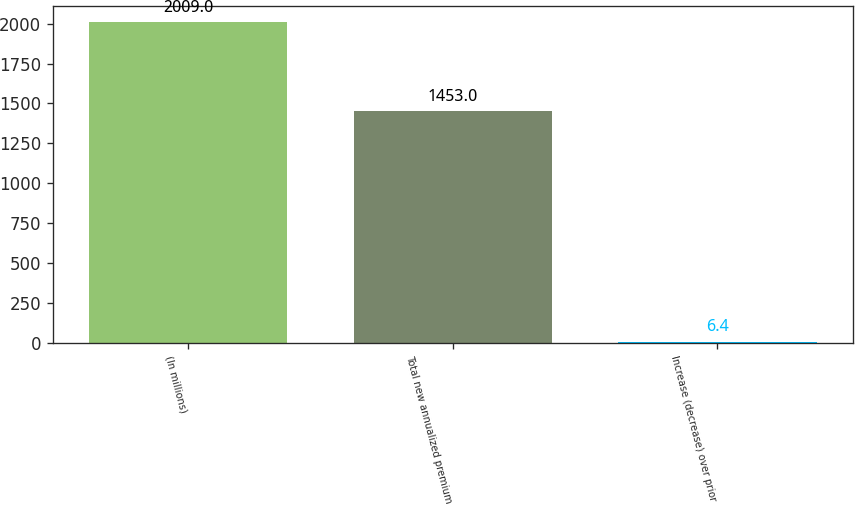Convert chart. <chart><loc_0><loc_0><loc_500><loc_500><bar_chart><fcel>(In millions)<fcel>Total new annualized premium<fcel>Increase (decrease) over prior<nl><fcel>2009<fcel>1453<fcel>6.4<nl></chart> 